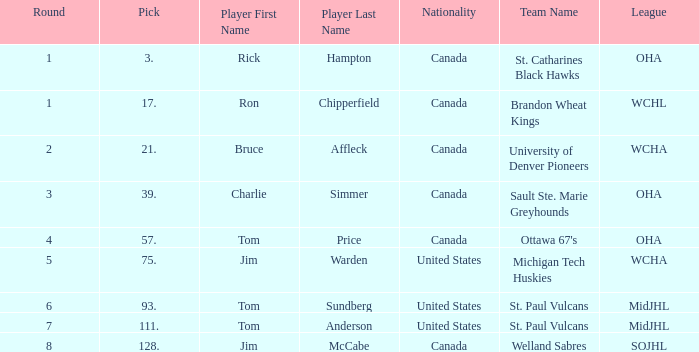Can you tell me the Nationality that has the Round smaller than 5, and the Player of bruce affleck? Canada. 